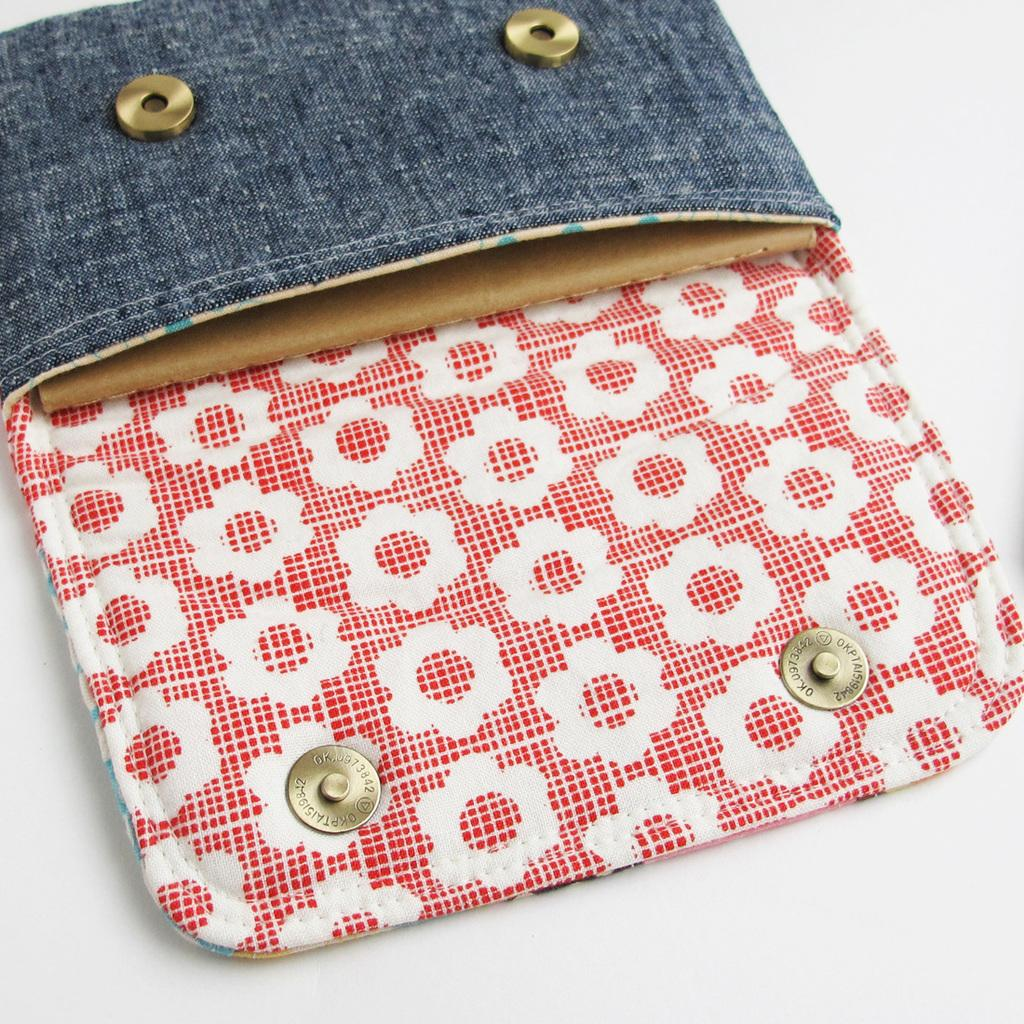What object is the main focus of the image? There is a wallet in the image. Where is the wallet placed in the image? The wallet is on a white color platform. How many bells are attached to the wallet in the image? There are no bells attached to the wallet in the image. What type of secretary is sitting next to the wallet in the image? There is no secretary present in the image; it only features a wallet on a white color platform. 